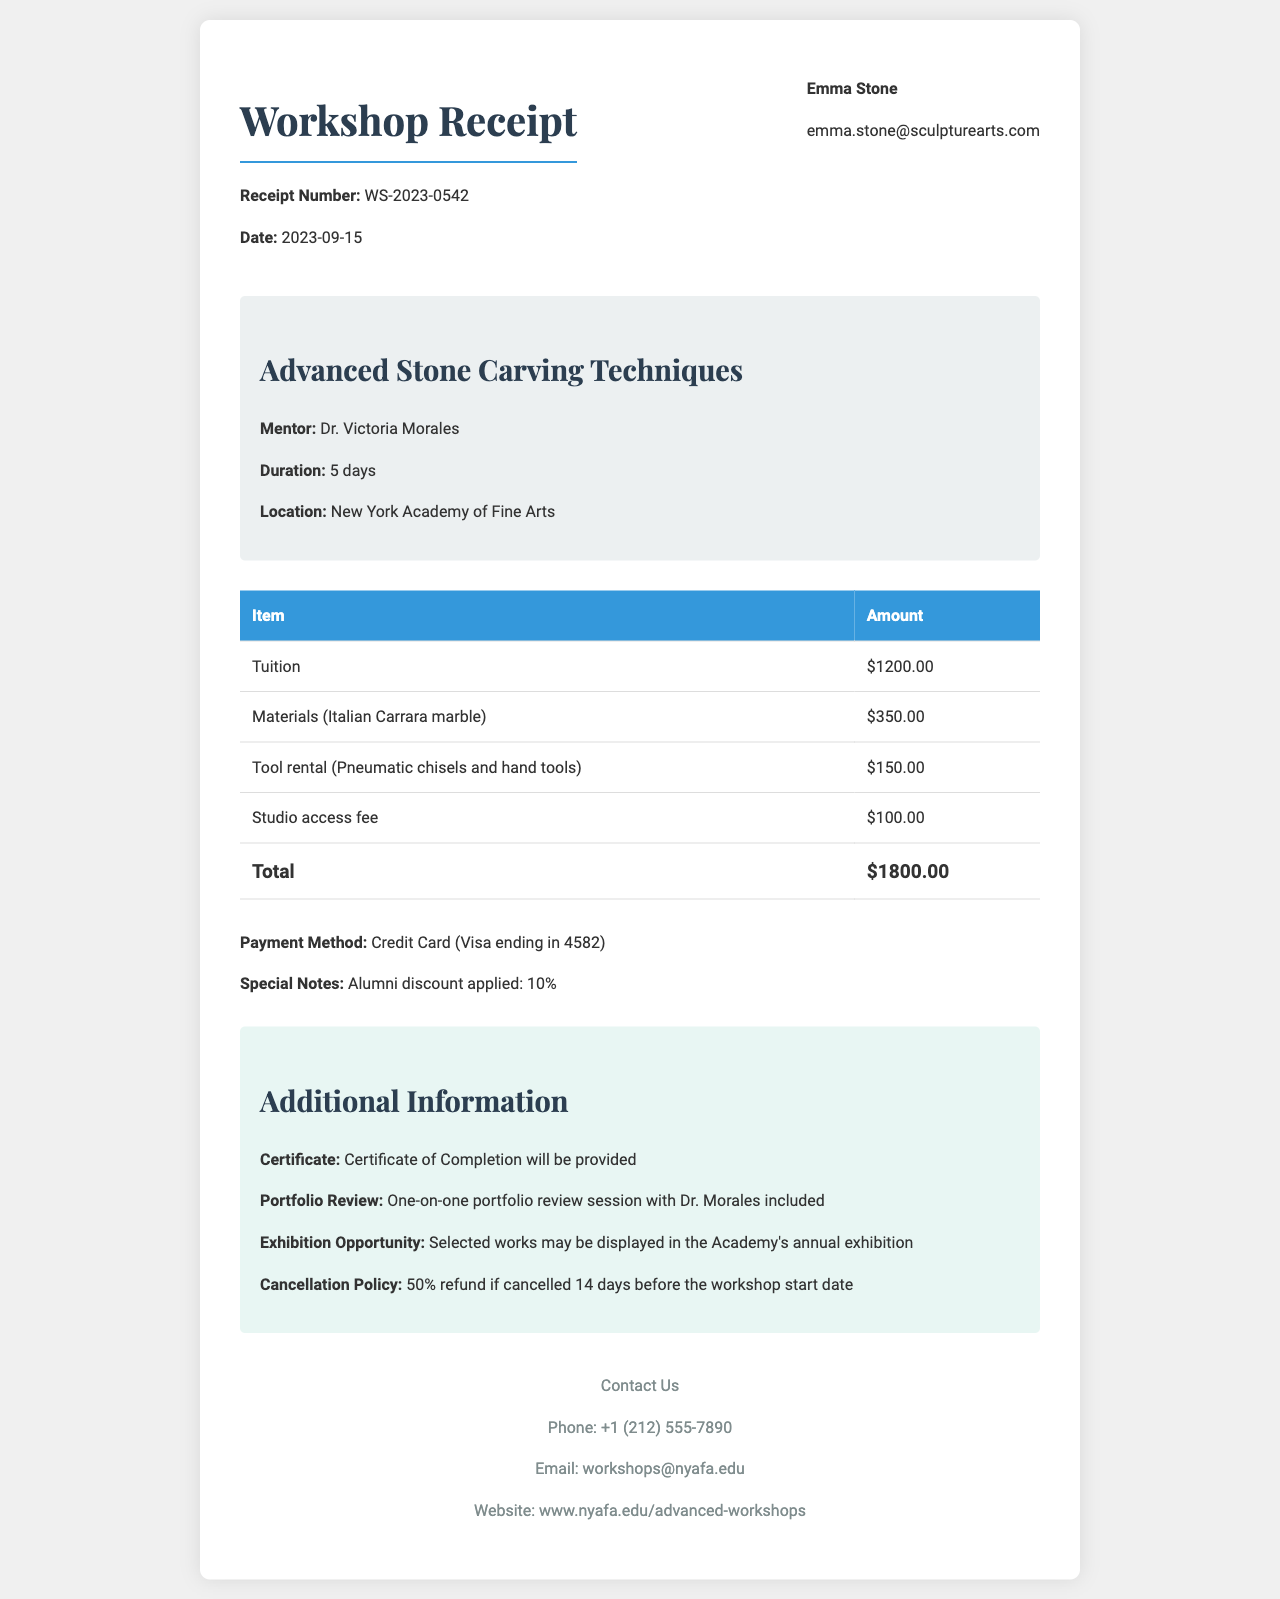What is the workshop title? The workshop title is explicitly mentioned in the document.
Answer: Advanced Stone Carving Techniques Who is the mentor professor? The name of the mentor professor is provided in the receipt.
Answer: Dr. Victoria Morales What is the total fee? The total fee summarizes all charges listed in the document.
Answer: $1800.00 What item has the highest cost? The fee breakdown lists individual item costs, allowing us to identify the one with the highest amount.
Answer: Tuition How many days does the workshop last? The duration of the workshop is mentioned in the document.
Answer: 5 days What payment method was used? The payment method specified in the receipt provides clear information about how the fee was settled.
Answer: Credit Card What is the cancellation policy? The cancellation policy outlines the terms related to refunds if the workshop is cancelled.
Answer: 50% refund if cancelled 14 days before the workshop start date Is there a discount applied? The special notes section indicates any discounts offered.
Answer: Yes, 10% Will a certificate be provided? The additional information section discusses whether participants receive any certification upon completion.
Answer: Yes 